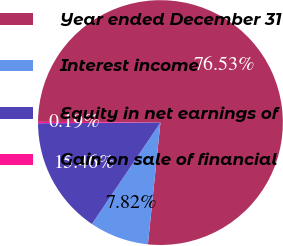<chart> <loc_0><loc_0><loc_500><loc_500><pie_chart><fcel>Year ended December 31<fcel>Interest income<fcel>Equity in net earnings of<fcel>Gain on sale of financial<nl><fcel>76.53%<fcel>7.82%<fcel>15.46%<fcel>0.19%<nl></chart> 